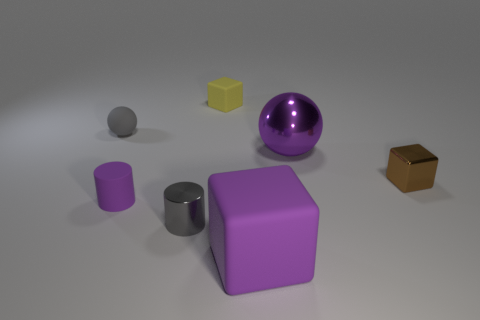Is there a tiny object that has the same material as the yellow cube?
Offer a terse response. Yes. What is the material of the gray sphere that is the same size as the gray cylinder?
Keep it short and to the point. Rubber. Are there fewer small spheres behind the big purple rubber cube than small cylinders that are in front of the gray sphere?
Give a very brief answer. Yes. What shape is the purple thing that is right of the tiny rubber cube and left of the metal ball?
Your answer should be compact. Cube. What number of purple things are the same shape as the yellow thing?
Keep it short and to the point. 1. The purple block that is the same material as the small yellow block is what size?
Give a very brief answer. Large. Is the number of big things greater than the number of yellow things?
Your response must be concise. Yes. What color is the sphere in front of the rubber sphere?
Your answer should be compact. Purple. What size is the purple thing that is both right of the gray metallic cylinder and in front of the big purple shiny object?
Make the answer very short. Large. How many cyan matte cylinders have the same size as the gray cylinder?
Your response must be concise. 0. 